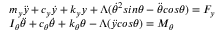Convert formula to latex. <formula><loc_0><loc_0><loc_500><loc_500>\begin{array} { r l } & { m _ { y } \ddot { y } + c _ { y } \dot { y } + k _ { y } y + \Lambda ( \dot { \theta } ^ { 2 } \sin \theta - \ddot { \theta } \cos \theta ) = F _ { y } } \\ & { I _ { \theta } \ddot { \theta } + c _ { \theta } \dot { \theta } + k _ { \theta } \theta - \Lambda ( \ddot { y } \cos \theta ) = M _ { \theta } } \end{array}</formula> 